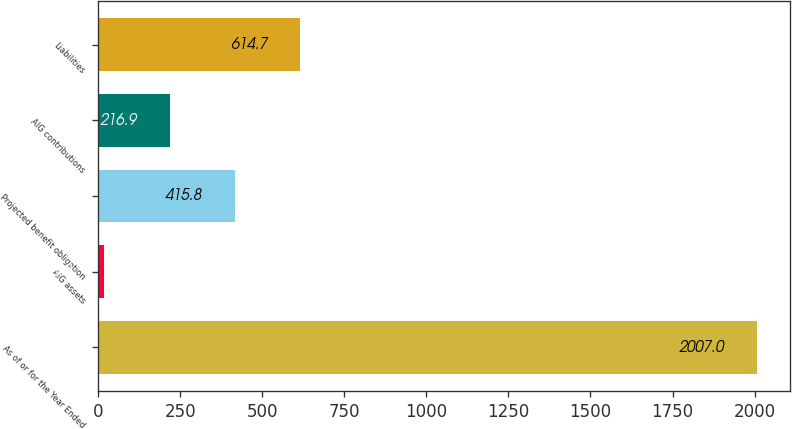Convert chart to OTSL. <chart><loc_0><loc_0><loc_500><loc_500><bar_chart><fcel>As of or for the Year Ended<fcel>AIG assets<fcel>Projected benefit obligation<fcel>AIG contributions<fcel>Liabilities<nl><fcel>2007<fcel>18<fcel>415.8<fcel>216.9<fcel>614.7<nl></chart> 